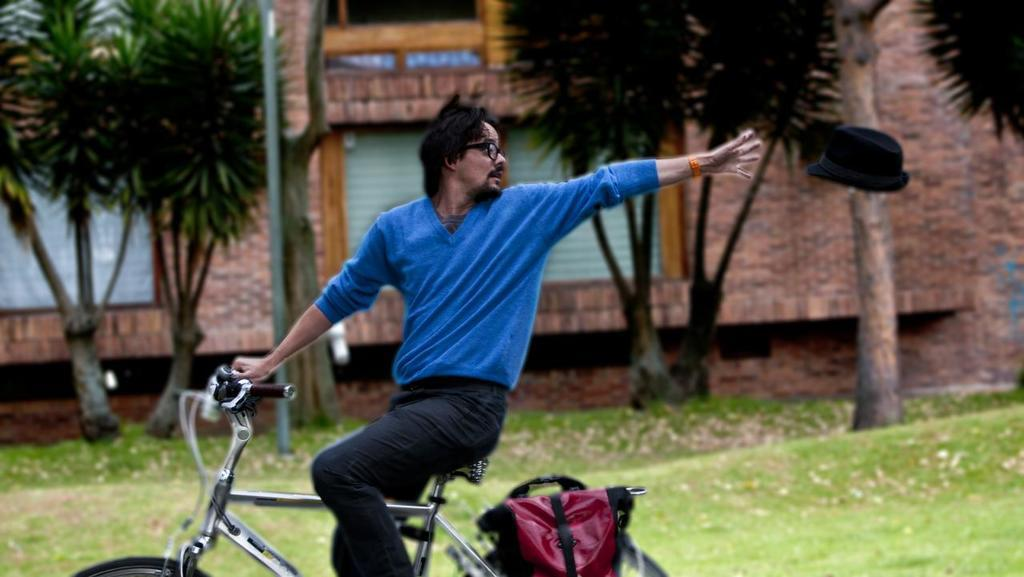What is the man in the image doing? The man is riding a bicycle in the image. What is the man wearing while riding the bicycle? The man is wearing a blue shirt and black pants. Can you describe any additional items in the image? Yes, there is a bag in the image, and it is maroon in color. What can be seen in the background of the image? There is a tree and a building in the background of the image. What type of decision-making system is visible in the image? There is no decision-making system present in the image. Can you describe the spot where the man is riding his bicycle? The image does not provide enough information to describe the specific spot where the man is riding his bicycle. 